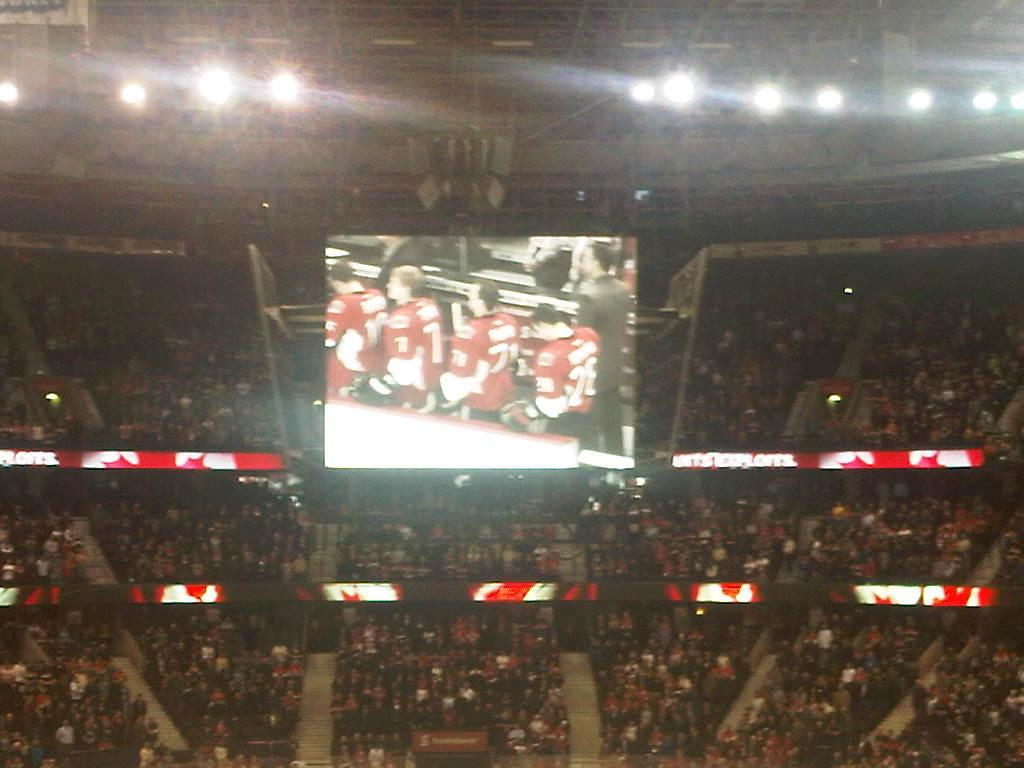What type of structure is shown in the image? There is a stadium in the image. How many people can be seen in the image? There are many people in the image. What decorative elements are present in the image? There are banners in the image. What device is used for displaying information or visuals in the image? There is a screen in the image. Can you describe what is being shown on the screen? There are people visible on the screen. What can be seen at the top of the image? There are lights at the top of the image. What type of animal can be seen grazing on the hill in the image? There is no hill or animal present in the image. How many men are visible on the screen in the image? The question cannot be answered definitively as the provided facts do not specify the gender of the people visible on the screen. 